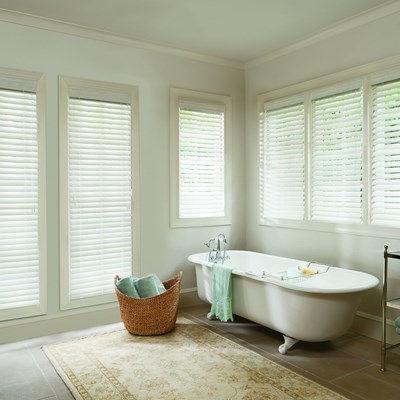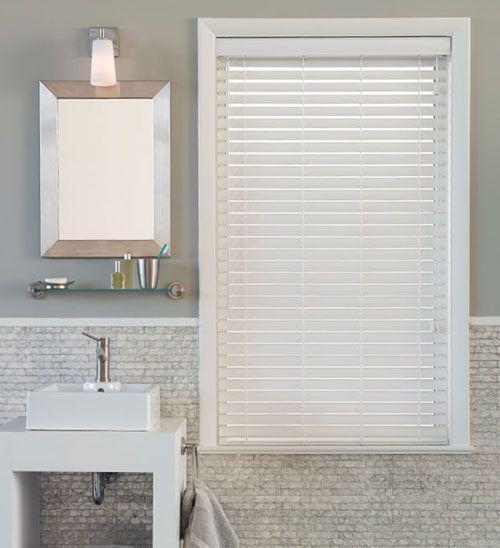The first image is the image on the left, the second image is the image on the right. Considering the images on both sides, is "The blinds in a room above a bathtub let in the light in the image on the left." valid? Answer yes or no. Yes. The first image is the image on the left, the second image is the image on the right. For the images displayed, is the sentence "There are two blinds." factually correct? Answer yes or no. No. 